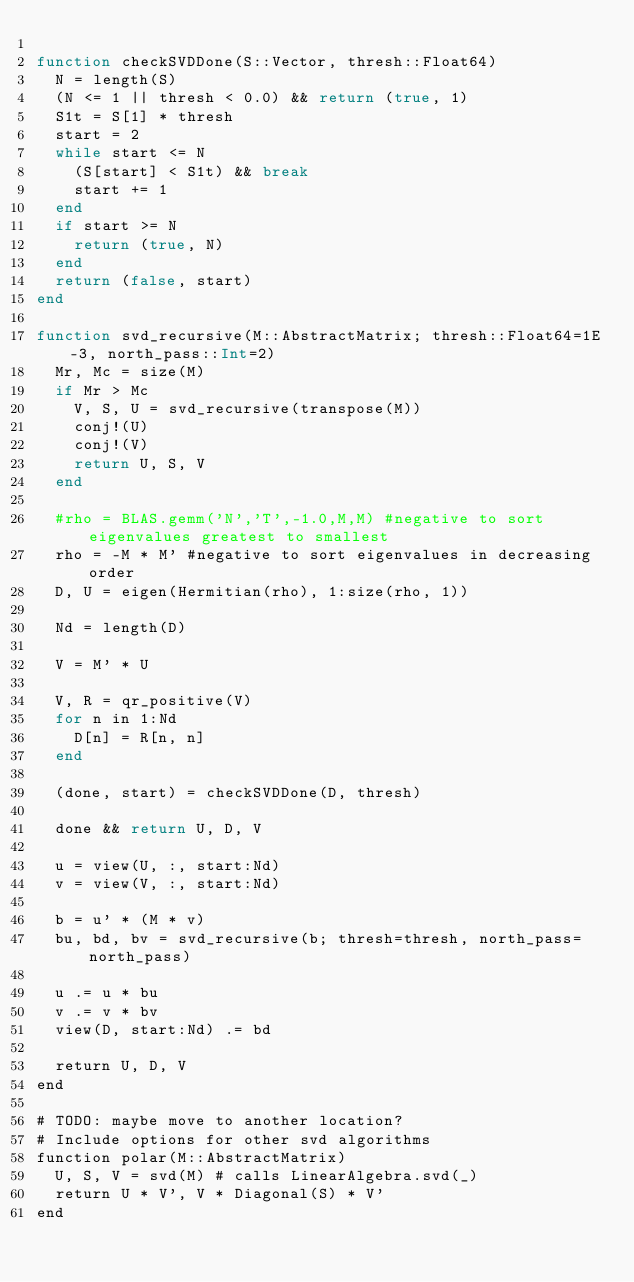Convert code to text. <code><loc_0><loc_0><loc_500><loc_500><_Julia_>
function checkSVDDone(S::Vector, thresh::Float64)
  N = length(S)
  (N <= 1 || thresh < 0.0) && return (true, 1)
  S1t = S[1] * thresh
  start = 2
  while start <= N
    (S[start] < S1t) && break
    start += 1
  end
  if start >= N
    return (true, N)
  end
  return (false, start)
end

function svd_recursive(M::AbstractMatrix; thresh::Float64=1E-3, north_pass::Int=2)
  Mr, Mc = size(M)
  if Mr > Mc
    V, S, U = svd_recursive(transpose(M))
    conj!(U)
    conj!(V)
    return U, S, V
  end

  #rho = BLAS.gemm('N','T',-1.0,M,M) #negative to sort eigenvalues greatest to smallest
  rho = -M * M' #negative to sort eigenvalues in decreasing order
  D, U = eigen(Hermitian(rho), 1:size(rho, 1))

  Nd = length(D)

  V = M' * U

  V, R = qr_positive(V)
  for n in 1:Nd
    D[n] = R[n, n]
  end

  (done, start) = checkSVDDone(D, thresh)

  done && return U, D, V

  u = view(U, :, start:Nd)
  v = view(V, :, start:Nd)

  b = u' * (M * v)
  bu, bd, bv = svd_recursive(b; thresh=thresh, north_pass=north_pass)

  u .= u * bu
  v .= v * bv
  view(D, start:Nd) .= bd

  return U, D, V
end

# TODO: maybe move to another location?
# Include options for other svd algorithms
function polar(M::AbstractMatrix)
  U, S, V = svd(M) # calls LinearAlgebra.svd(_)
  return U * V', V * Diagonal(S) * V'
end
</code> 